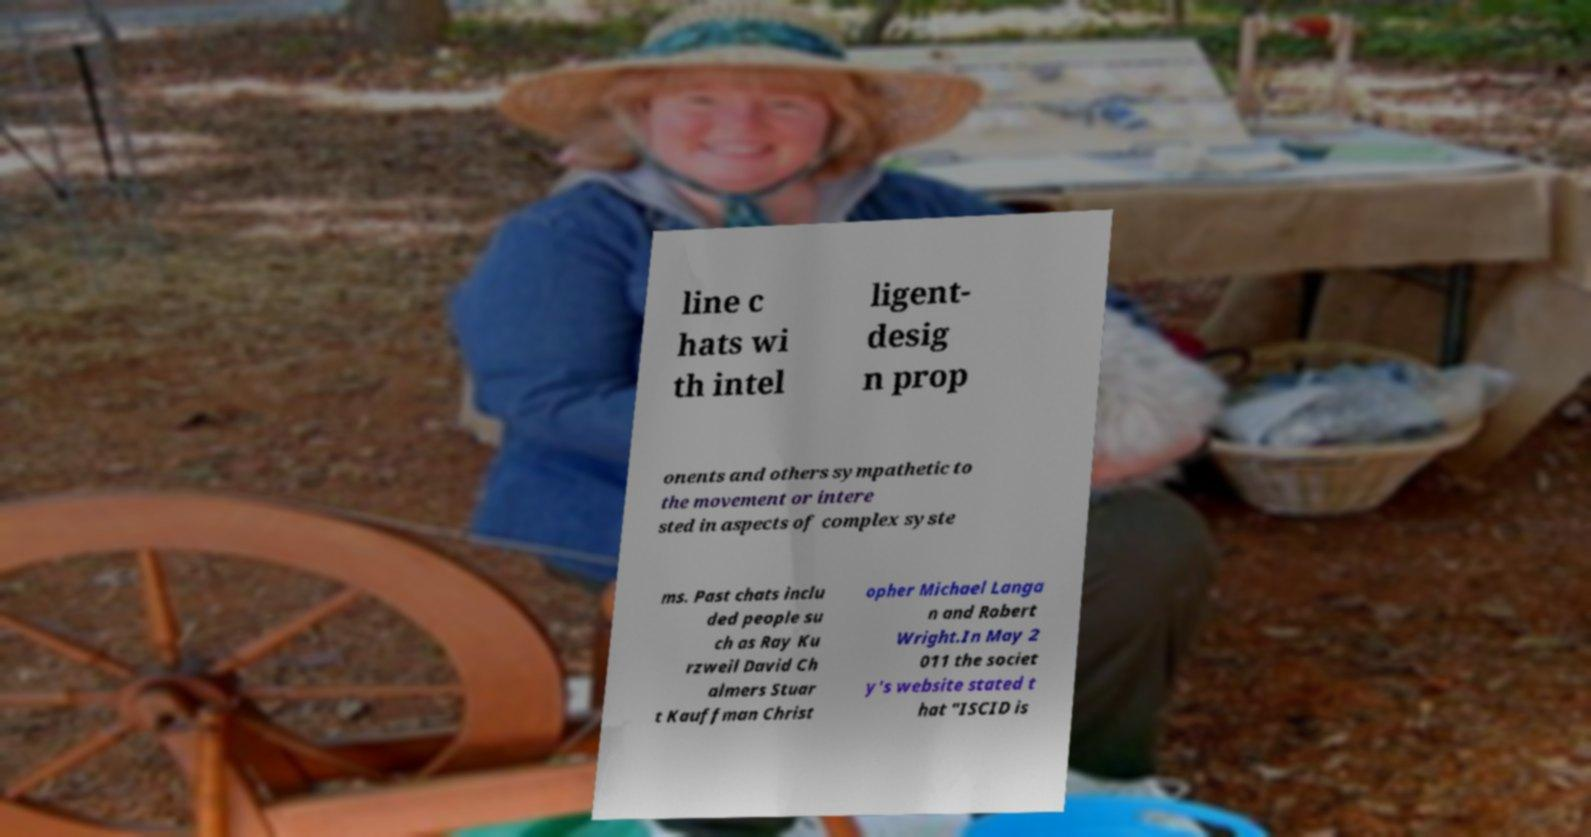Could you extract and type out the text from this image? line c hats wi th intel ligent- desig n prop onents and others sympathetic to the movement or intere sted in aspects of complex syste ms. Past chats inclu ded people su ch as Ray Ku rzweil David Ch almers Stuar t Kauffman Christ opher Michael Langa n and Robert Wright.In May 2 011 the societ y's website stated t hat "ISCID is 